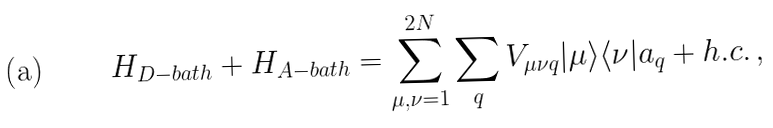Convert formula to latex. <formula><loc_0><loc_0><loc_500><loc_500>H _ { D - b a t h } + H _ { A - b a t h } = \sum _ { \mu , \nu = 1 } ^ { 2 N } \sum _ { q } V _ { \mu \nu q } | \mu \rangle \langle \nu | a _ { q } + h . c . \, ,</formula> 